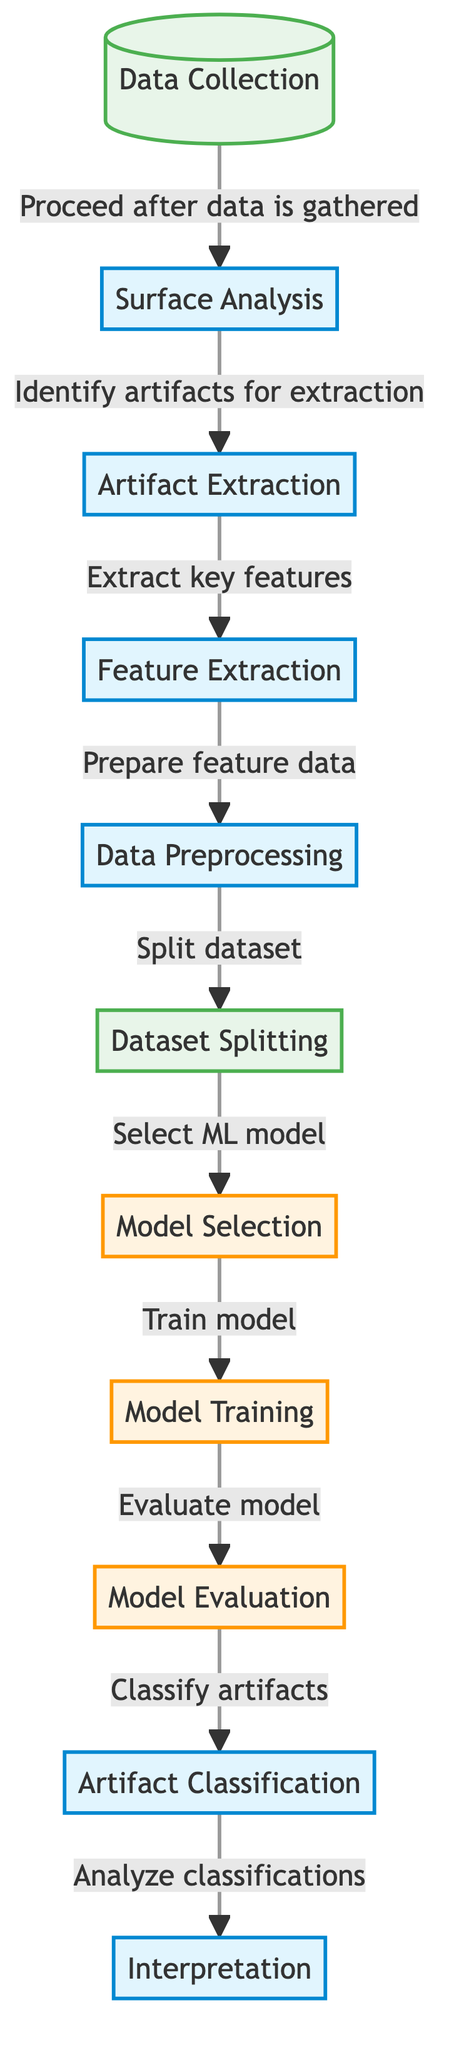What is the first step in the machine learning diagram? The first step in the diagram is labeled "Data Collection," which is where the entire process begins according to the flowchart.
Answer: Data Collection How many process nodes are present in the diagram? There are six process nodes: Surface Analysis, Artifact Extraction, Feature Extraction, Data Preprocessing, Model Selection, Model Training, Model Evaluation, Artifact Classification, and Interpretation, making a total of eight.
Answer: Eight What node follows "Feature Extraction"? The node that follows "Feature Extraction" is labeled "Data Preprocessing," indicating that after features are extracted, preprocessing is needed.
Answer: Data Preprocessing What indicates the transition from data collection to analysis? The transition is indicated by the arrow from "Data Collection" to "Surface Analysis" with the text "Proceed after data is gathered," showing the flow from collecting data to analyzing it.
Answer: Proceed after data is gathered How does the "Model Evaluation" contribute to the overall classification process? "Model Evaluation" is crucial as it assesses the performance of the trained model before proceeding to "Artifact Classification," ensuring that only well-evaluated models are used for classifying artifacts.
Answer: Assesses performance Which node is specifically responsible for extracting key features? The node responsible for extracting key features is "Artifact Extraction," which is the step where essential characteristics of the artifacts are identified.
Answer: Artifact Extraction What is the final step in the classification model? The final step in the classification model is labeled "Interpretation," which involves analyzing the classifications made by the machine learning model.
Answer: Interpretation What type of model selection is shown in the diagram? The diagram illustrates "Model Selection," where a specific machine learning model is chosen to proceed with the training phase.
Answer: Model Selection What is the main purpose of the "Dataset Splitting" node? The main purpose of the "Dataset Splitting" node is to divide the dataset into training and testing sets, which is critical for evaluating the model’s performance effectively.
Answer: Divide dataset 